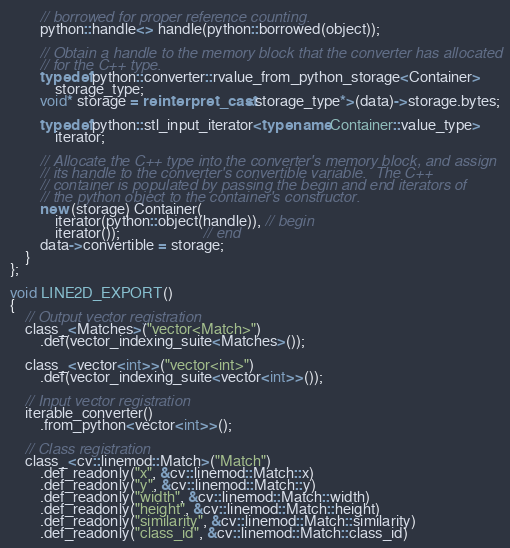<code> <loc_0><loc_0><loc_500><loc_500><_C++_>		// borrowed for proper reference counting.
		python::handle<> handle(python::borrowed(object));

		// Obtain a handle to the memory block that the converter has allocated
		// for the C++ type.
		typedef python::converter::rvalue_from_python_storage<Container>
			storage_type;
		void* storage = reinterpret_cast<storage_type*>(data)->storage.bytes;

		typedef python::stl_input_iterator<typename Container::value_type>
			iterator;

		// Allocate the C++ type into the converter's memory block, and assign
		// its handle to the converter's convertible variable.  The C++
		// container is populated by passing the begin and end iterators of
		// the python object to the container's constructor.
		new (storage) Container(
			iterator(python::object(handle)), // begin
			iterator());                      // end
		data->convertible = storage;
	}
};

void LINE2D_EXPORT()
{
	// Output vector registration
	class_<Matches>("vector<Match>")
		.def(vector_indexing_suite<Matches>());

	class_<vector<int>>("vector<int>")
		.def(vector_indexing_suite<vector<int>>());

	// Input vector registration
	iterable_converter()
		.from_python<vector<int>>();

	// Class registration
	class_<cv::linemod::Match>("Match")
		.def_readonly("x", &cv::linemod::Match::x)
		.def_readonly("y", &cv::linemod::Match::y)
		.def_readonly("width", &cv::linemod::Match::width)
		.def_readonly("height", &cv::linemod::Match::height)
		.def_readonly("similarity", &cv::linemod::Match::similarity)
		.def_readonly("class_id", &cv::linemod::Match::class_id)</code> 